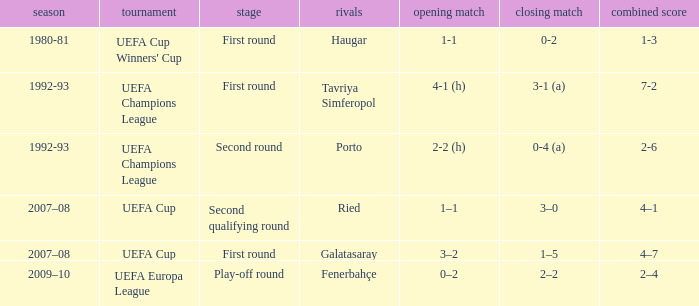 what's the competition where 1st leg is 4-1 (h) UEFA Champions League. 